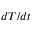<formula> <loc_0><loc_0><loc_500><loc_500>d T / d t</formula> 